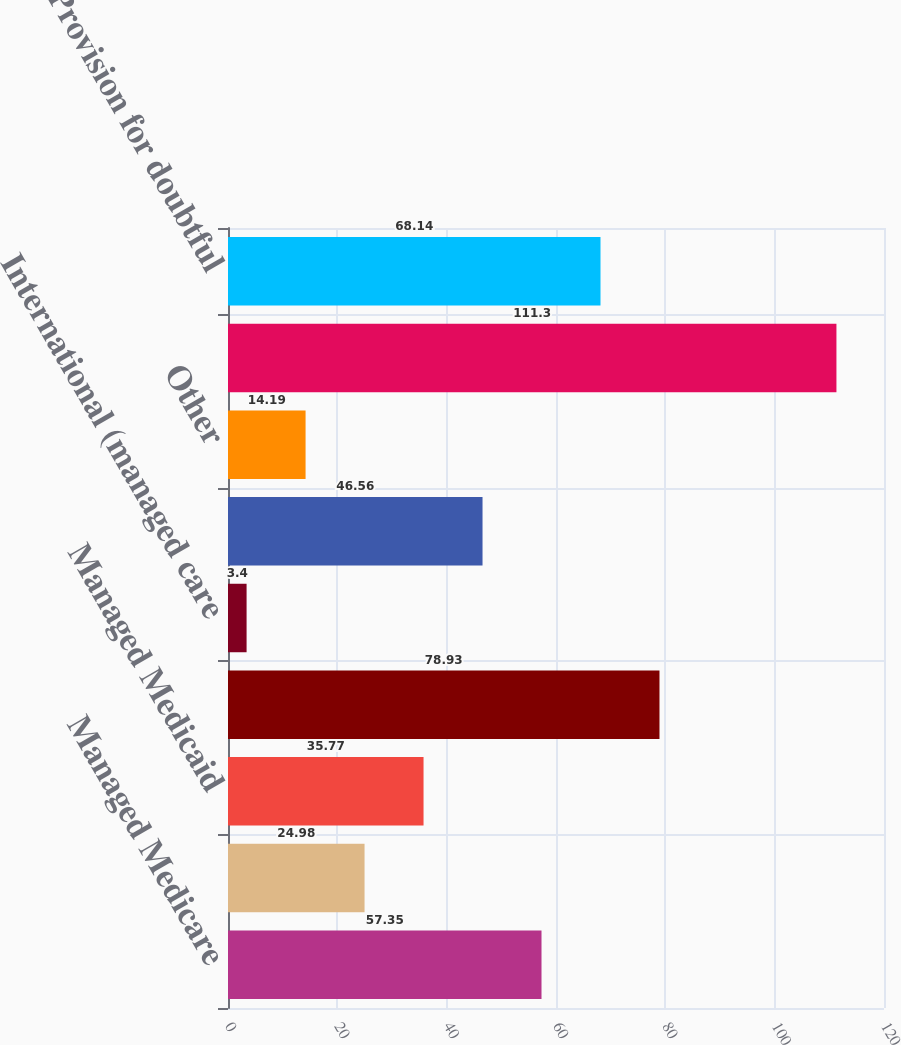Convert chart to OTSL. <chart><loc_0><loc_0><loc_500><loc_500><bar_chart><fcel>Managed Medicare<fcel>Medicaid<fcel>Managed Medicaid<fcel>Managed care and other<fcel>International (managed care<fcel>Uninsured<fcel>Other<fcel>Revenues before provision for<fcel>Provision for doubtful<nl><fcel>57.35<fcel>24.98<fcel>35.77<fcel>78.93<fcel>3.4<fcel>46.56<fcel>14.19<fcel>111.3<fcel>68.14<nl></chart> 